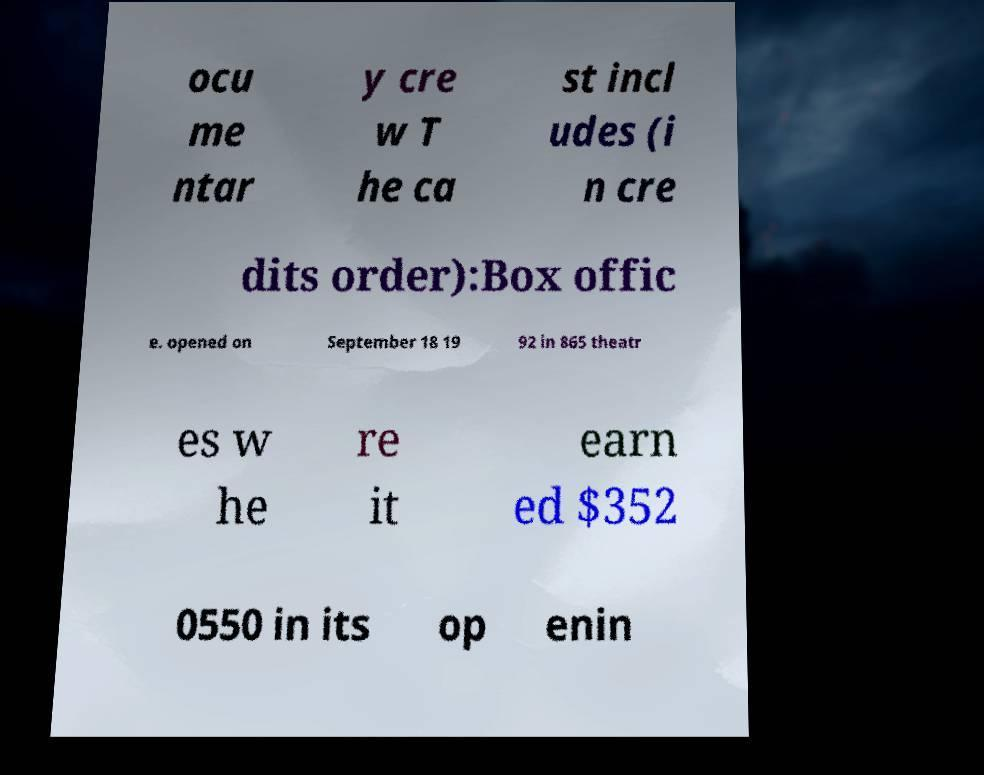There's text embedded in this image that I need extracted. Can you transcribe it verbatim? ocu me ntar y cre w T he ca st incl udes (i n cre dits order):Box offic e. opened on September 18 19 92 in 865 theatr es w he re it earn ed $352 0550 in its op enin 